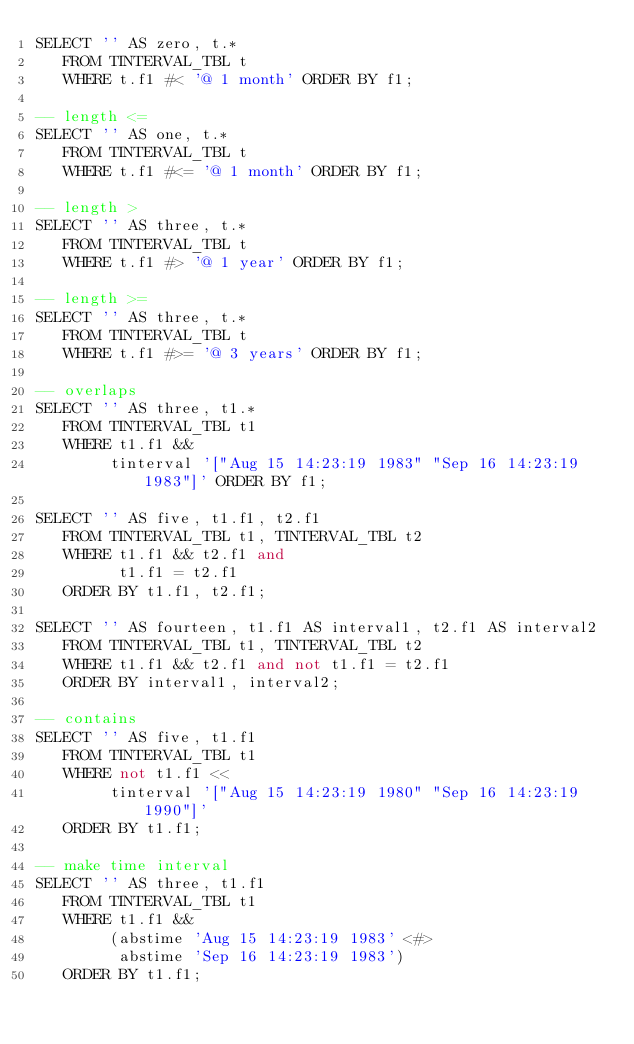Convert code to text. <code><loc_0><loc_0><loc_500><loc_500><_SQL_>SELECT '' AS zero, t.*
   FROM TINTERVAL_TBL t
   WHERE t.f1 #< '@ 1 month' ORDER BY f1;

-- length <=
SELECT '' AS one, t.*
   FROM TINTERVAL_TBL t
   WHERE t.f1 #<= '@ 1 month' ORDER BY f1;

-- length >
SELECT '' AS three, t.*
   FROM TINTERVAL_TBL t
   WHERE t.f1 #> '@ 1 year' ORDER BY f1;

-- length >=
SELECT '' AS three, t.*
   FROM TINTERVAL_TBL t
   WHERE t.f1 #>= '@ 3 years' ORDER BY f1;

-- overlaps
SELECT '' AS three, t1.*
   FROM TINTERVAL_TBL t1
   WHERE t1.f1 &&
        tinterval '["Aug 15 14:23:19 1983" "Sep 16 14:23:19 1983"]' ORDER BY f1;

SELECT '' AS five, t1.f1, t2.f1
   FROM TINTERVAL_TBL t1, TINTERVAL_TBL t2
   WHERE t1.f1 && t2.f1 and
         t1.f1 = t2.f1
   ORDER BY t1.f1, t2.f1;

SELECT '' AS fourteen, t1.f1 AS interval1, t2.f1 AS interval2
   FROM TINTERVAL_TBL t1, TINTERVAL_TBL t2
   WHERE t1.f1 && t2.f1 and not t1.f1 = t2.f1
   ORDER BY interval1, interval2;

-- contains
SELECT '' AS five, t1.f1
   FROM TINTERVAL_TBL t1
   WHERE not t1.f1 <<
        tinterval '["Aug 15 14:23:19 1980" "Sep 16 14:23:19 1990"]'
   ORDER BY t1.f1;

-- make time interval
SELECT '' AS three, t1.f1
   FROM TINTERVAL_TBL t1
   WHERE t1.f1 &&
        (abstime 'Aug 15 14:23:19 1983' <#>
         abstime 'Sep 16 14:23:19 1983')
   ORDER BY t1.f1;
</code> 